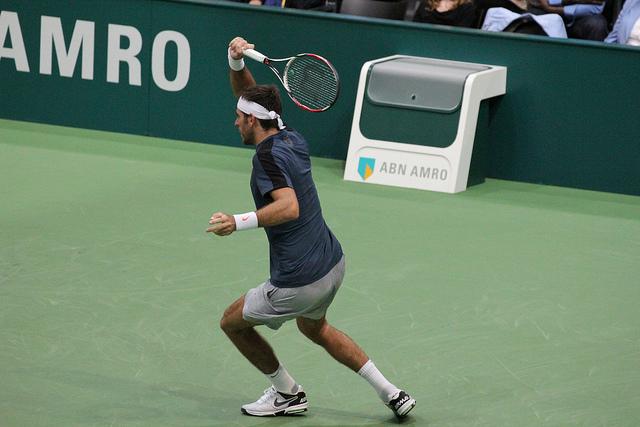What color is the wall behind the man?
Answer briefly. Green. What color band is around the man's right wrist?
Be succinct. White. Is the man going to hit the ball?
Concise answer only. Yes. What sport is this?
Keep it brief. Tennis. What does the top sign say?
Give a very brief answer. Amro. What color is his headband?
Keep it brief. White. What color is the grass?
Short answer required. Green. 